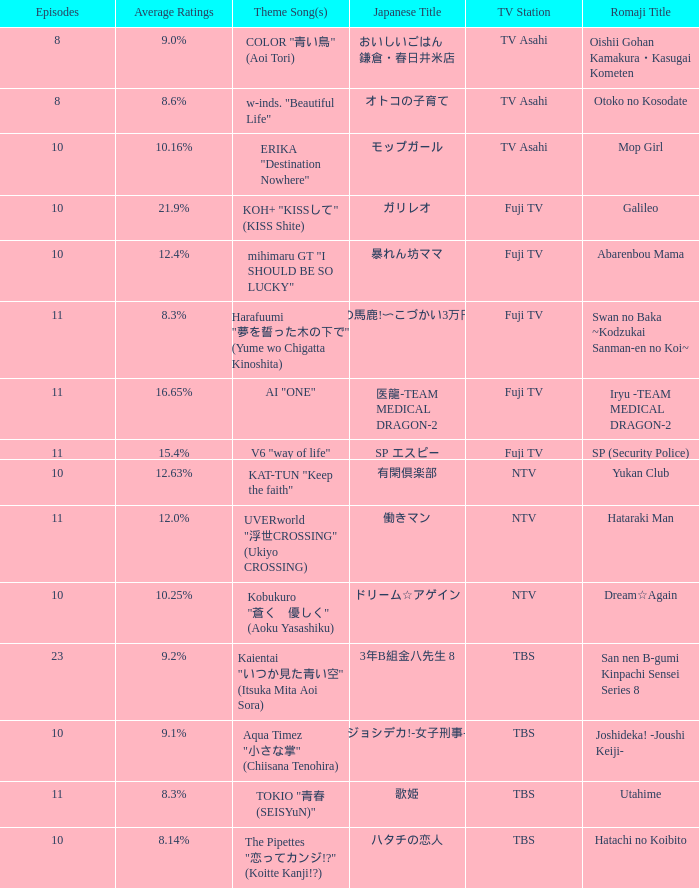What Episode has a Theme Song of koh+ "kissして" (kiss shite)? 10.0. 